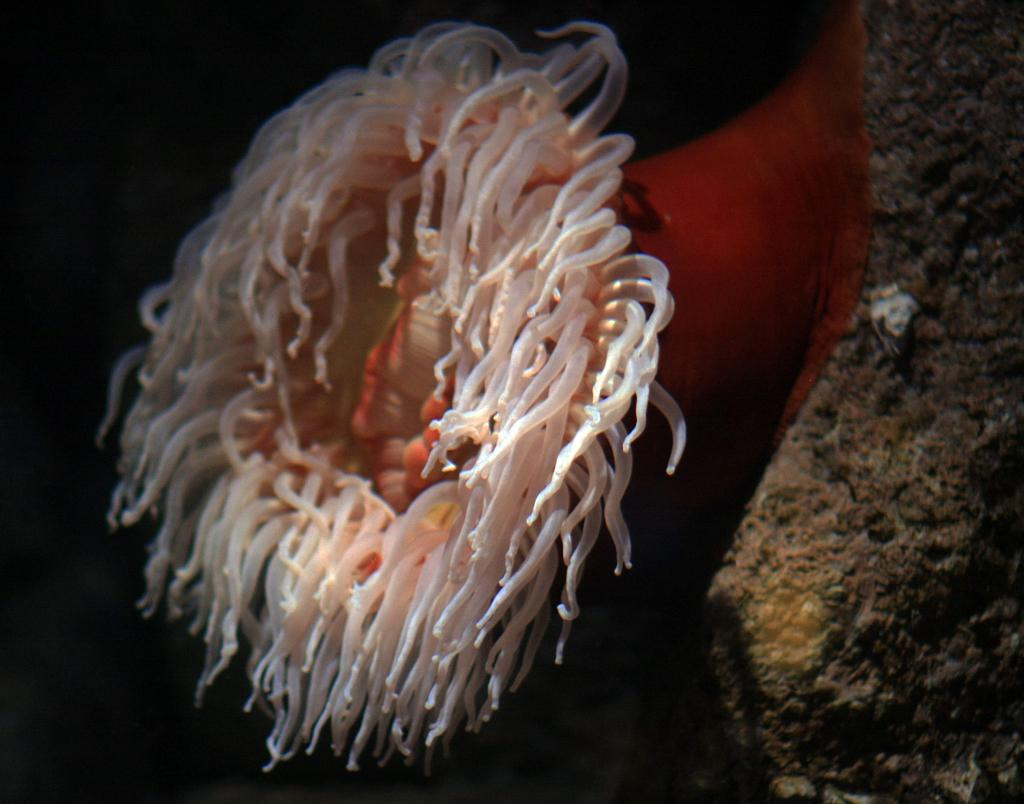What subject matter is the image related to? The image is related to marine biology. What type of environment or organisms might be depicted in the image? The image likely contains marine life or a marine environment. What type of gun is being used to cause a reaction in the marine life in the image? There is no gun or any indication of a reaction being caused in the image; it is related to marine biology and likely contains marine life or a marine environment. 